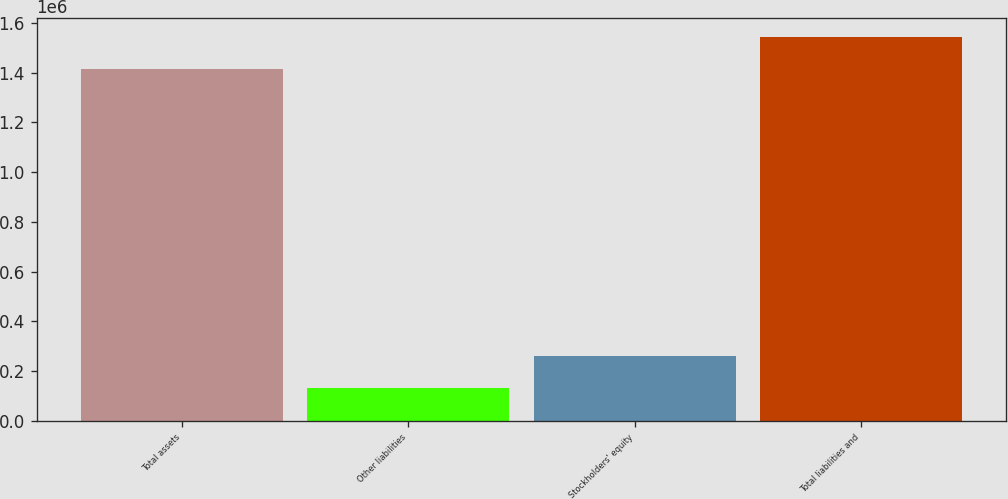Convert chart to OTSL. <chart><loc_0><loc_0><loc_500><loc_500><bar_chart><fcel>Total assets<fcel>Other liabilities<fcel>Stockholders' equity<fcel>Total liabilities and<nl><fcel>1.41348e+06<fcel>130362<fcel>258673<fcel>1.54179e+06<nl></chart> 